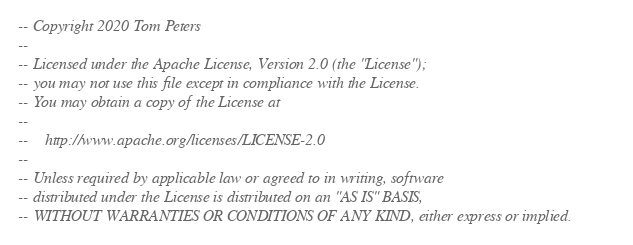<code> <loc_0><loc_0><loc_500><loc_500><_SQL_>-- Copyright 2020 Tom Peters
-- 
-- Licensed under the Apache License, Version 2.0 (the "License");
-- you may not use this file except in compliance with the License.
-- You may obtain a copy of the License at
-- 
--    http://www.apache.org/licenses/LICENSE-2.0
-- 
-- Unless required by applicable law or agreed to in writing, software
-- distributed under the License is distributed on an "AS IS" BASIS,
-- WITHOUT WARRANTIES OR CONDITIONS OF ANY KIND, either express or implied.</code> 